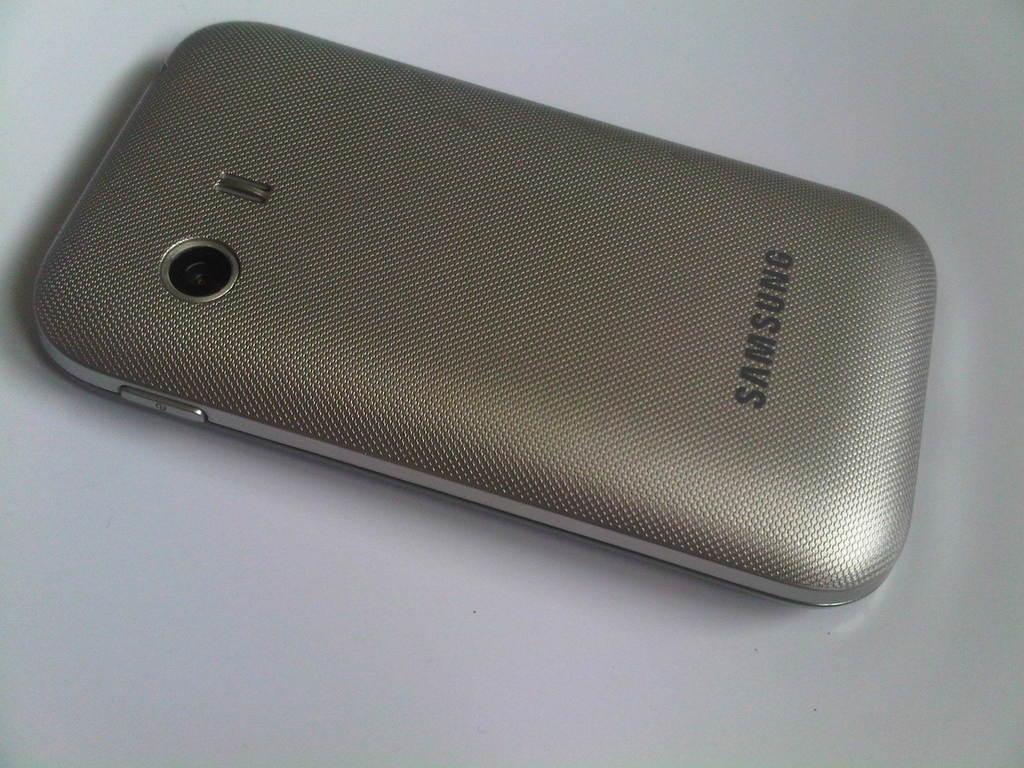What brand of phone is this?
Your answer should be very brief. Samsung. 